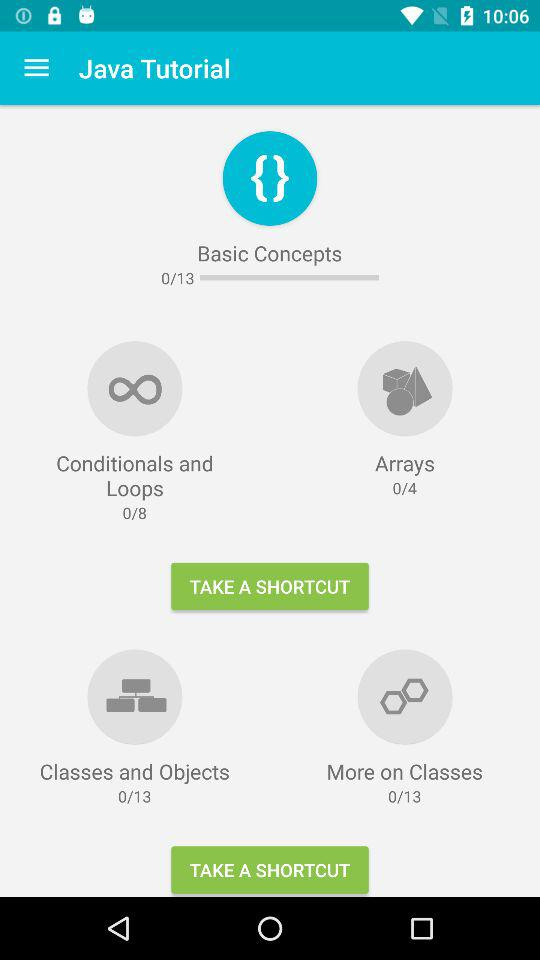How many total tutorials are there on the basic concepts of Java? There are a total of 13 tutorials. 